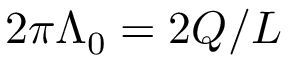Convert formula to latex. <formula><loc_0><loc_0><loc_500><loc_500>2 \pi \Lambda _ { 0 } = 2 Q / L</formula> 